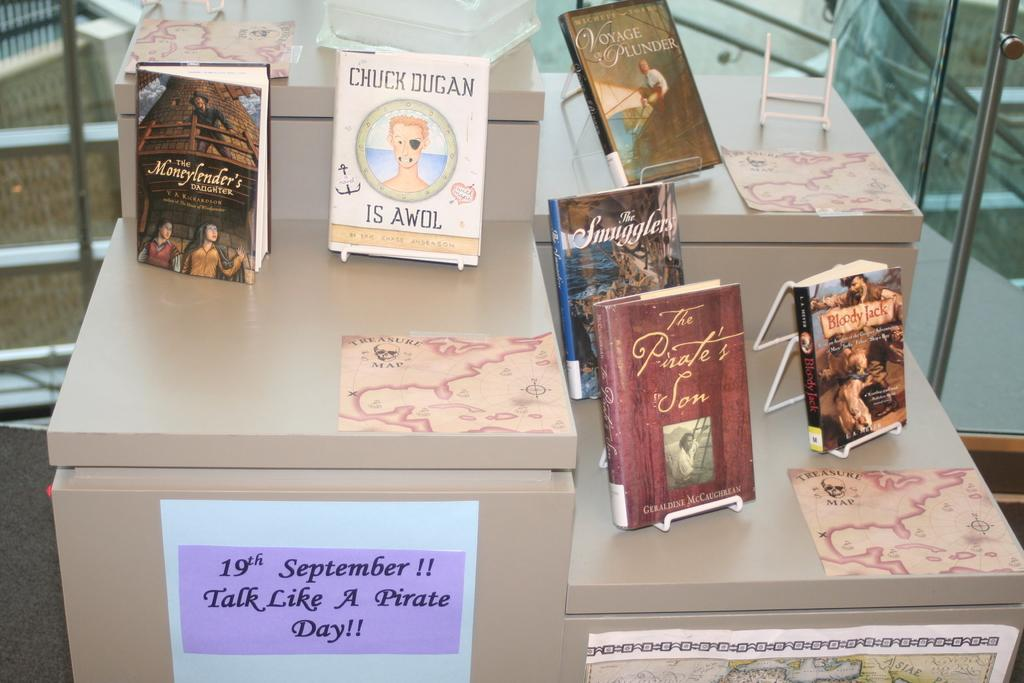Provide a one-sentence caption for the provided image. A small collection of books for Talk Like a Pirate Day on September 19. 